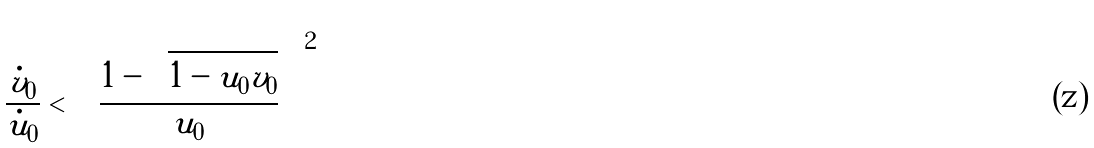<formula> <loc_0><loc_0><loc_500><loc_500>\frac { \dot { v } _ { 0 } } { \dot { u } _ { 0 } } < \left ( \frac { 1 - \sqrt { 1 - u _ { 0 } v _ { 0 } } } { u _ { 0 } } \right ) ^ { 2 }</formula> 